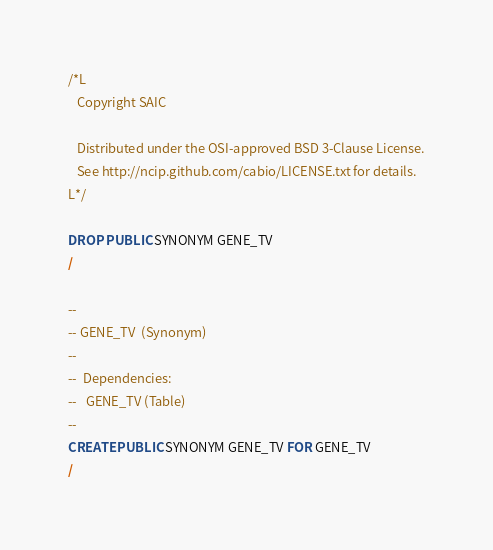Convert code to text. <code><loc_0><loc_0><loc_500><loc_500><_SQL_>/*L
   Copyright SAIC

   Distributed under the OSI-approved BSD 3-Clause License.
   See http://ncip.github.com/cabio/LICENSE.txt for details.
L*/

DROP PUBLIC SYNONYM GENE_TV
/

--
-- GENE_TV  (Synonym) 
--
--  Dependencies: 
--   GENE_TV (Table)
--
CREATE PUBLIC SYNONYM GENE_TV FOR GENE_TV
/


</code> 